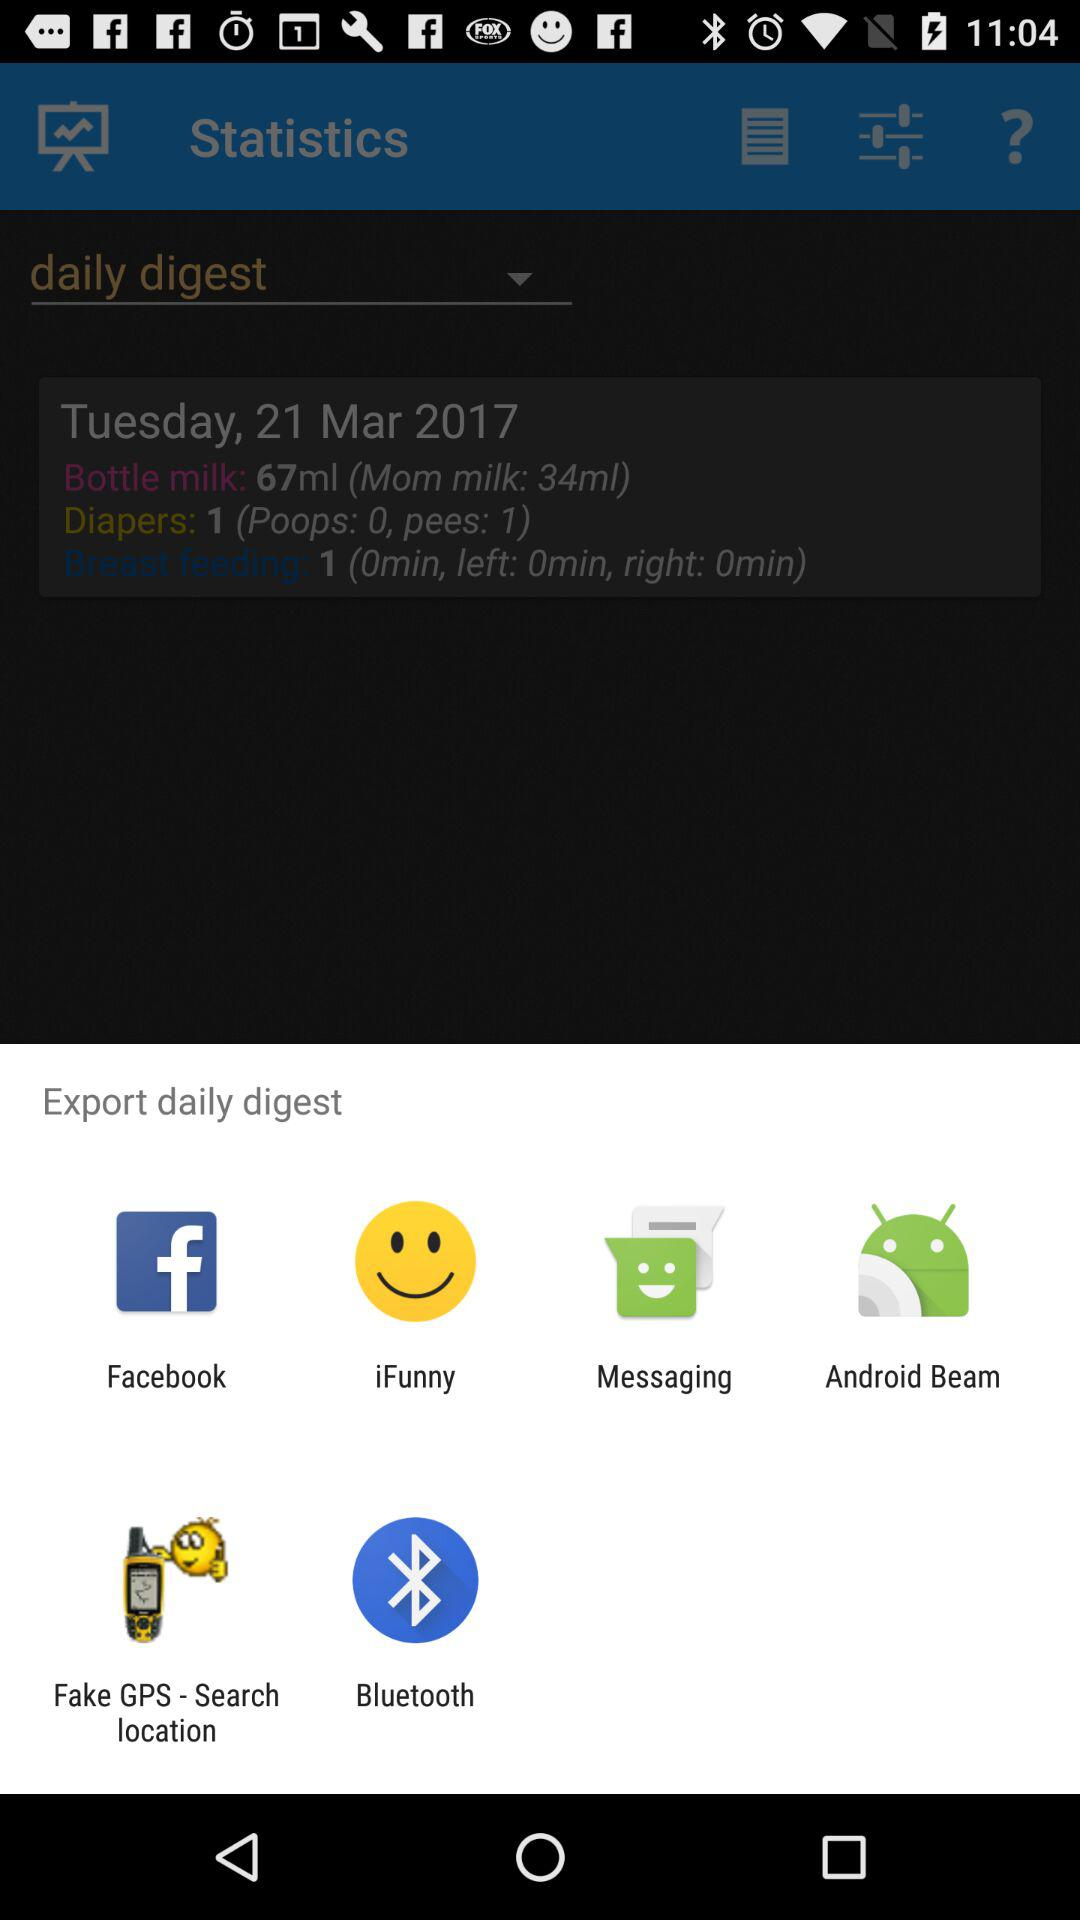How many more ml of mom milk was used than breast feeding?
Answer the question using a single word or phrase. 33 